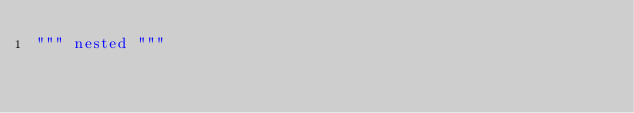Convert code to text. <code><loc_0><loc_0><loc_500><loc_500><_Python_>""" nested """
</code> 